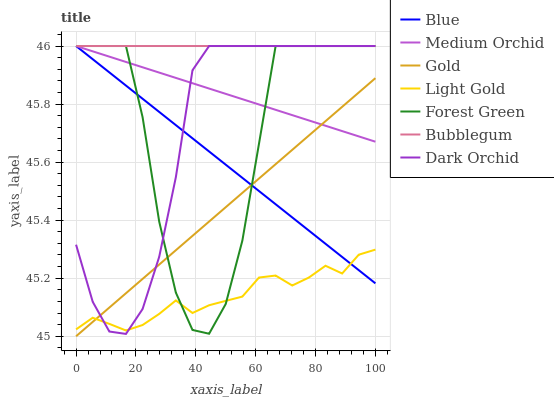Does Light Gold have the minimum area under the curve?
Answer yes or no. Yes. Does Bubblegum have the maximum area under the curve?
Answer yes or no. Yes. Does Gold have the minimum area under the curve?
Answer yes or no. No. Does Gold have the maximum area under the curve?
Answer yes or no. No. Is Bubblegum the smoothest?
Answer yes or no. Yes. Is Forest Green the roughest?
Answer yes or no. Yes. Is Gold the smoothest?
Answer yes or no. No. Is Gold the roughest?
Answer yes or no. No. Does Gold have the lowest value?
Answer yes or no. Yes. Does Medium Orchid have the lowest value?
Answer yes or no. No. Does Dark Orchid have the highest value?
Answer yes or no. Yes. Does Gold have the highest value?
Answer yes or no. No. Is Light Gold less than Medium Orchid?
Answer yes or no. Yes. Is Bubblegum greater than Gold?
Answer yes or no. Yes. Does Dark Orchid intersect Light Gold?
Answer yes or no. Yes. Is Dark Orchid less than Light Gold?
Answer yes or no. No. Is Dark Orchid greater than Light Gold?
Answer yes or no. No. Does Light Gold intersect Medium Orchid?
Answer yes or no. No. 